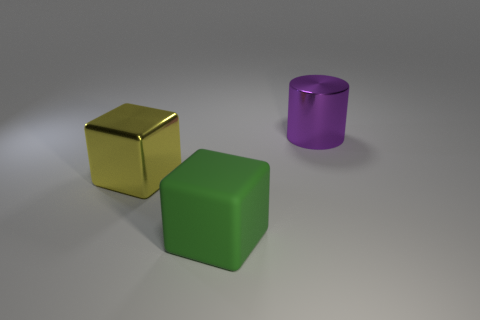Add 2 rubber things. How many objects exist? 5 Subtract all blocks. How many objects are left? 1 Subtract all large purple cylinders. Subtract all green things. How many objects are left? 1 Add 2 yellow shiny blocks. How many yellow shiny blocks are left? 3 Add 2 purple shiny cylinders. How many purple shiny cylinders exist? 3 Subtract 0 cyan cubes. How many objects are left? 3 